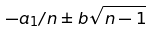Convert formula to latex. <formula><loc_0><loc_0><loc_500><loc_500>- a _ { 1 } / n \pm b \sqrt { n - 1 }</formula> 